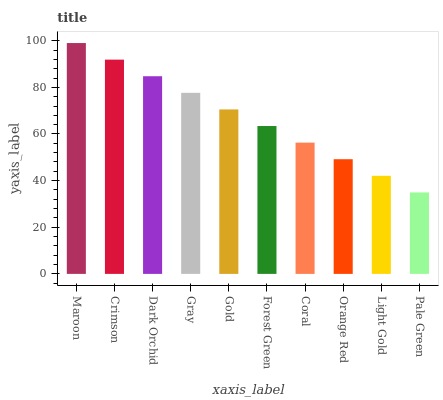Is Pale Green the minimum?
Answer yes or no. Yes. Is Maroon the maximum?
Answer yes or no. Yes. Is Crimson the minimum?
Answer yes or no. No. Is Crimson the maximum?
Answer yes or no. No. Is Maroon greater than Crimson?
Answer yes or no. Yes. Is Crimson less than Maroon?
Answer yes or no. Yes. Is Crimson greater than Maroon?
Answer yes or no. No. Is Maroon less than Crimson?
Answer yes or no. No. Is Gold the high median?
Answer yes or no. Yes. Is Forest Green the low median?
Answer yes or no. Yes. Is Forest Green the high median?
Answer yes or no. No. Is Maroon the low median?
Answer yes or no. No. 